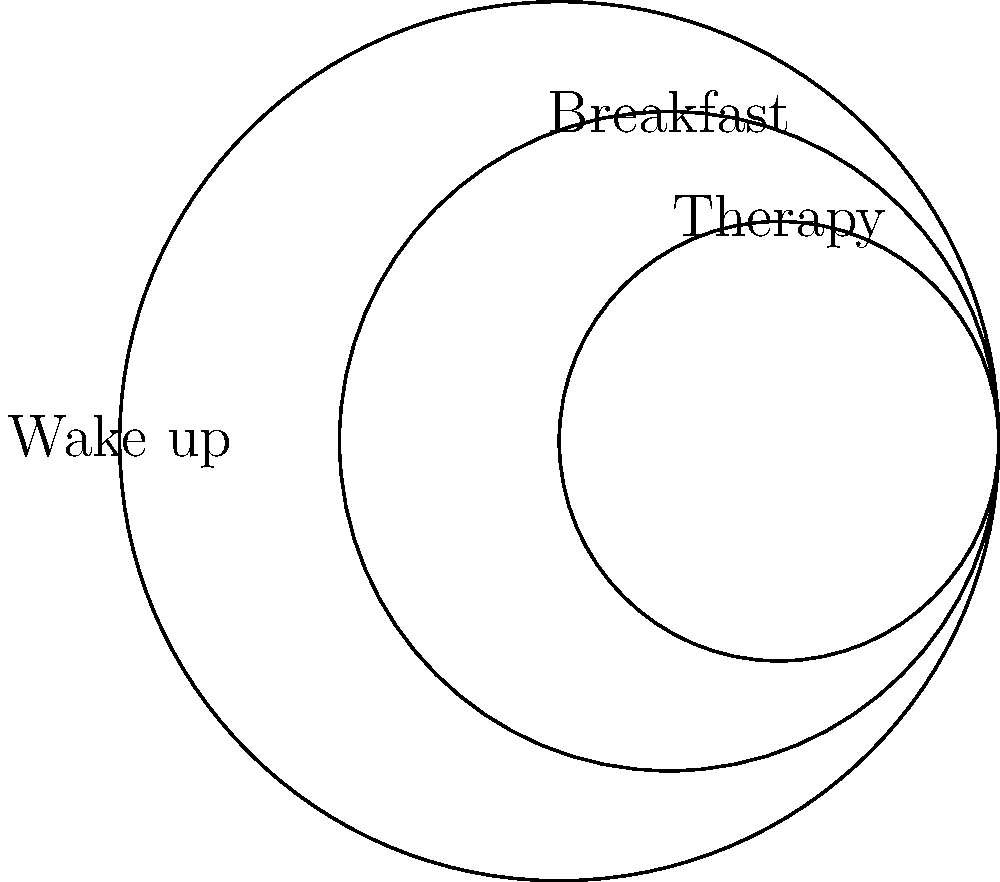In the context of establishing a structured daily routine for a child with a developmental disorder, consider the interconnected circles representing different activities. If the largest circle represents "Wake up," the middle-sized circle "Breakfast," and the smallest circle "Therapy," what is the correct sequence of these activities based on their arrangement? To determine the correct sequence of activities, we need to analyze the arrangement of the interconnected circles:

1. The largest circle is on the left and represents "Wake up."
2. The middle-sized circle is partially inside the largest circle and represents "Breakfast."
3. The smallest circle is partially inside the middle-sized circle and represents "Therapy."

This arrangement suggests a progression from left to right, with each subsequent activity contained within the previous one. The sequence follows a logical order for a morning routine:

1. The child first wakes up (largest circle).
2. After waking up, the child has breakfast (middle-sized circle).
3. Following breakfast, the child attends therapy (smallest circle).

This sequence aligns with a typical morning routine and provides a structured approach for a child with a developmental disorder, helping to establish predictability and routine in their day.
Answer: Wake up → Breakfast → Therapy 